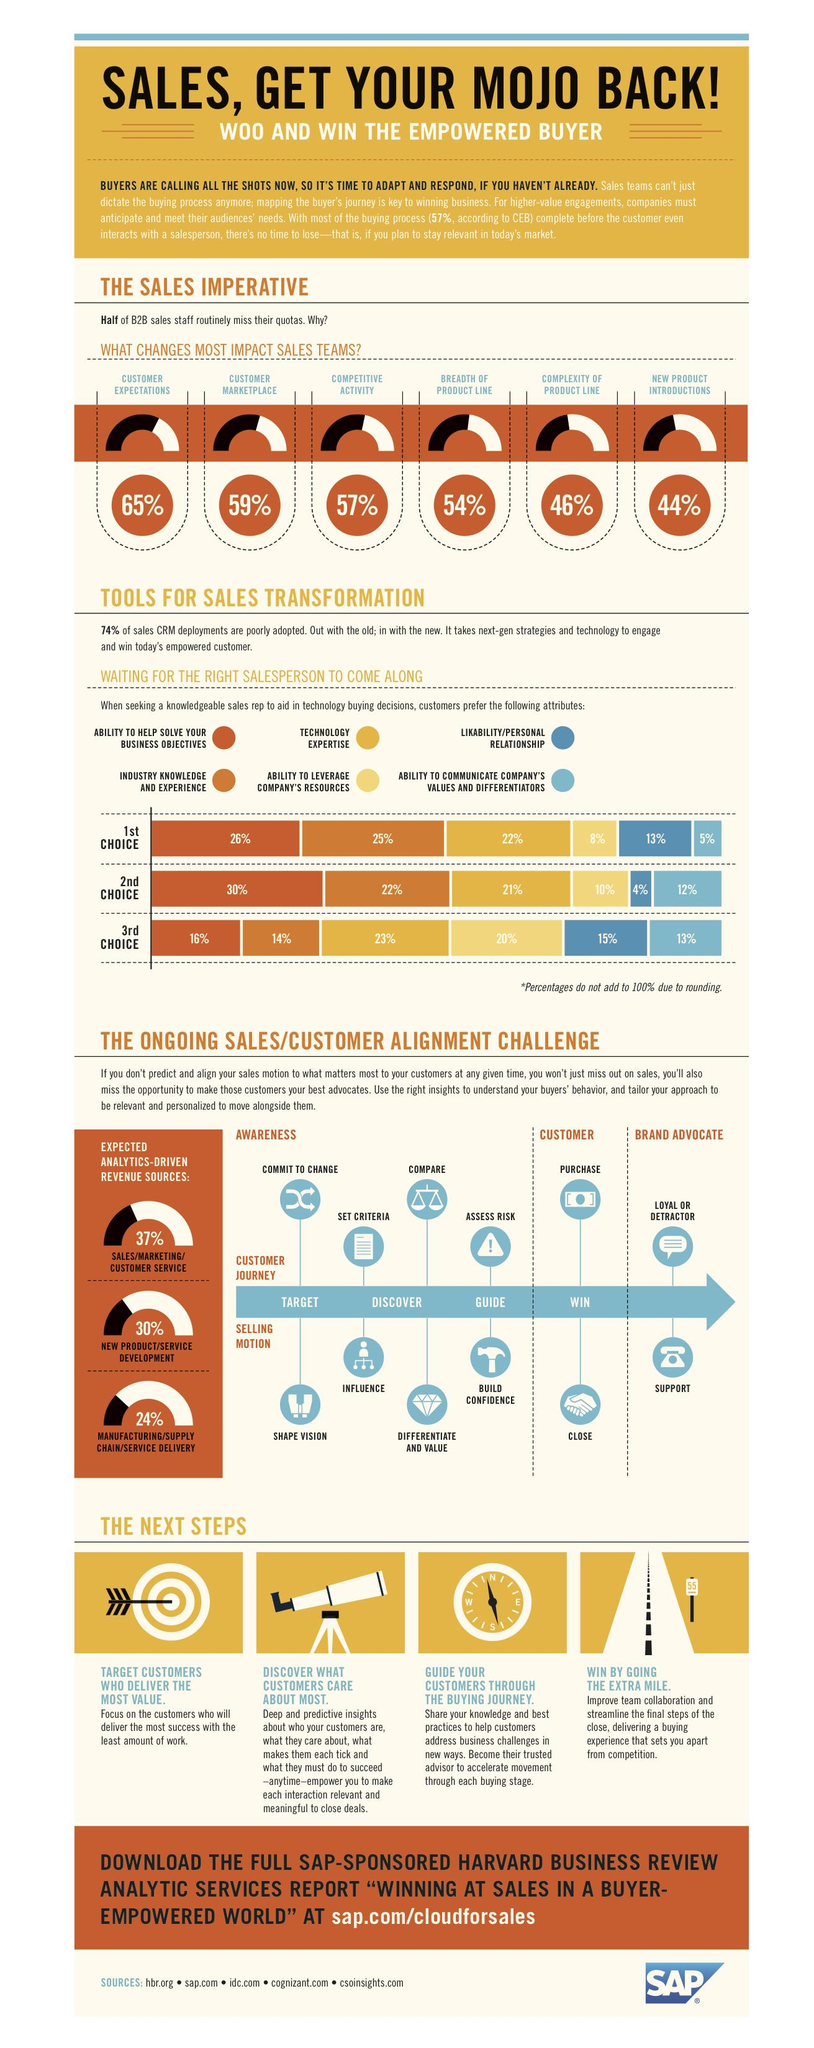Specify some key components in this picture. After a business helps customers differentiate and value their product or service, the next step that customers typically take is to assess the risk associated with the product or service. Competitive activity is estimated to have a 57% impact on sales. According to the given statistic, 14% of businesses consider sales representatives with industry knowledge and experience as their third choice when hiring new employees. According to the given statistic, 22% of businesses prioritize hiring a sales representative who has technology expertise as their top choice. After a customer purchases a product or service, the next step provided by the business in the Sales motion is Support. 